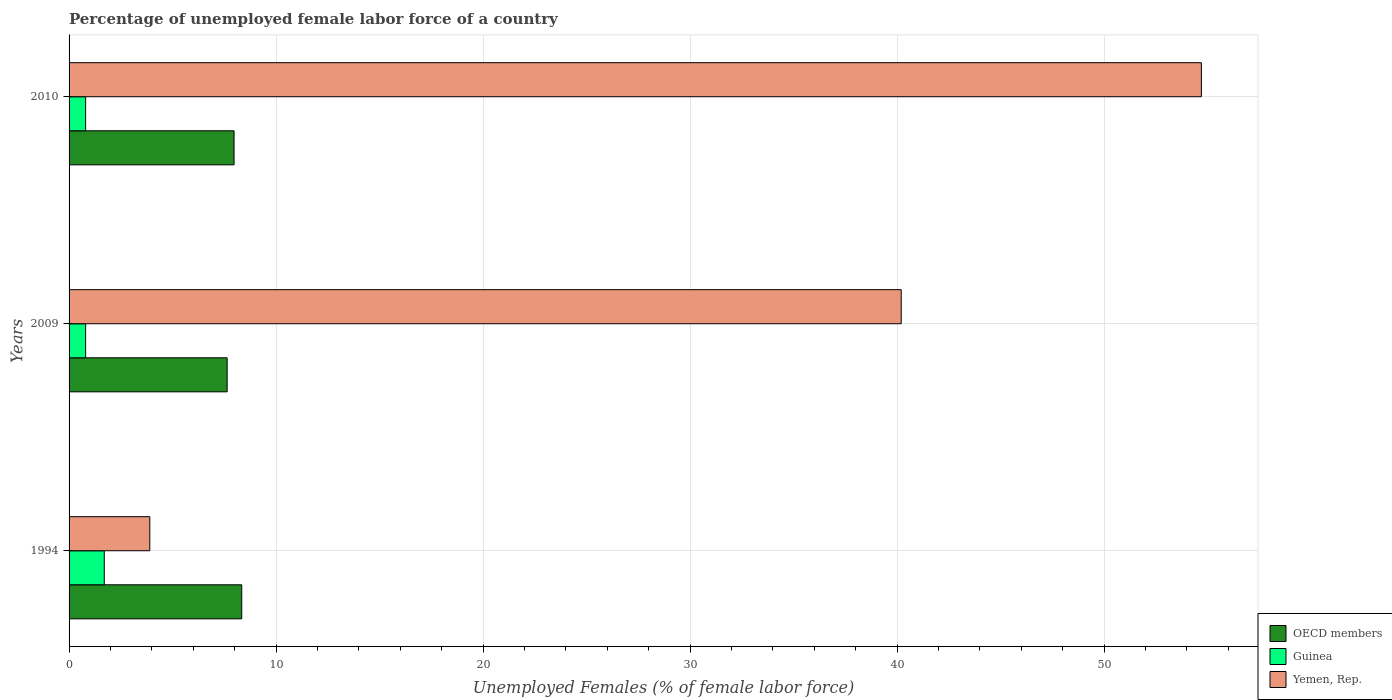How many different coloured bars are there?
Provide a short and direct response. 3. Are the number of bars on each tick of the Y-axis equal?
Your answer should be very brief. Yes. What is the percentage of unemployed female labor force in Guinea in 2009?
Your response must be concise. 0.8. Across all years, what is the maximum percentage of unemployed female labor force in OECD members?
Give a very brief answer. 8.34. Across all years, what is the minimum percentage of unemployed female labor force in Yemen, Rep.?
Keep it short and to the point. 3.9. In which year was the percentage of unemployed female labor force in OECD members maximum?
Provide a short and direct response. 1994. What is the total percentage of unemployed female labor force in Guinea in the graph?
Provide a short and direct response. 3.3. What is the difference between the percentage of unemployed female labor force in OECD members in 1994 and that in 2009?
Your answer should be very brief. 0.7. What is the difference between the percentage of unemployed female labor force in Guinea in 1994 and the percentage of unemployed female labor force in OECD members in 2009?
Offer a terse response. -5.94. What is the average percentage of unemployed female labor force in Guinea per year?
Give a very brief answer. 1.1. In the year 1994, what is the difference between the percentage of unemployed female labor force in Yemen, Rep. and percentage of unemployed female labor force in Guinea?
Your answer should be compact. 2.2. What is the ratio of the percentage of unemployed female labor force in OECD members in 2009 to that in 2010?
Offer a terse response. 0.96. What is the difference between the highest and the second highest percentage of unemployed female labor force in Guinea?
Provide a short and direct response. 0.9. What is the difference between the highest and the lowest percentage of unemployed female labor force in Guinea?
Ensure brevity in your answer.  0.9. Is the sum of the percentage of unemployed female labor force in Yemen, Rep. in 2009 and 2010 greater than the maximum percentage of unemployed female labor force in OECD members across all years?
Offer a very short reply. Yes. What does the 1st bar from the top in 1994 represents?
Give a very brief answer. Yemen, Rep. What does the 2nd bar from the bottom in 2010 represents?
Provide a succinct answer. Guinea. How many bars are there?
Offer a very short reply. 9. What is the difference between two consecutive major ticks on the X-axis?
Your response must be concise. 10. Are the values on the major ticks of X-axis written in scientific E-notation?
Give a very brief answer. No. Does the graph contain any zero values?
Offer a very short reply. No. Does the graph contain grids?
Make the answer very short. Yes. Where does the legend appear in the graph?
Your answer should be compact. Bottom right. How many legend labels are there?
Make the answer very short. 3. What is the title of the graph?
Your answer should be compact. Percentage of unemployed female labor force of a country. Does "Slovenia" appear as one of the legend labels in the graph?
Your answer should be very brief. No. What is the label or title of the X-axis?
Offer a terse response. Unemployed Females (% of female labor force). What is the label or title of the Y-axis?
Your response must be concise. Years. What is the Unemployed Females (% of female labor force) of OECD members in 1994?
Offer a terse response. 8.34. What is the Unemployed Females (% of female labor force) in Guinea in 1994?
Offer a very short reply. 1.7. What is the Unemployed Females (% of female labor force) in Yemen, Rep. in 1994?
Provide a succinct answer. 3.9. What is the Unemployed Females (% of female labor force) in OECD members in 2009?
Keep it short and to the point. 7.64. What is the Unemployed Females (% of female labor force) of Guinea in 2009?
Offer a very short reply. 0.8. What is the Unemployed Females (% of female labor force) in Yemen, Rep. in 2009?
Offer a very short reply. 40.2. What is the Unemployed Females (% of female labor force) in OECD members in 2010?
Make the answer very short. 7.97. What is the Unemployed Females (% of female labor force) in Guinea in 2010?
Offer a very short reply. 0.8. What is the Unemployed Females (% of female labor force) in Yemen, Rep. in 2010?
Offer a terse response. 54.7. Across all years, what is the maximum Unemployed Females (% of female labor force) of OECD members?
Provide a succinct answer. 8.34. Across all years, what is the maximum Unemployed Females (% of female labor force) in Guinea?
Your response must be concise. 1.7. Across all years, what is the maximum Unemployed Females (% of female labor force) in Yemen, Rep.?
Your answer should be compact. 54.7. Across all years, what is the minimum Unemployed Females (% of female labor force) in OECD members?
Offer a very short reply. 7.64. Across all years, what is the minimum Unemployed Females (% of female labor force) of Guinea?
Provide a short and direct response. 0.8. Across all years, what is the minimum Unemployed Females (% of female labor force) of Yemen, Rep.?
Give a very brief answer. 3.9. What is the total Unemployed Females (% of female labor force) of OECD members in the graph?
Your answer should be very brief. 23.95. What is the total Unemployed Females (% of female labor force) in Yemen, Rep. in the graph?
Keep it short and to the point. 98.8. What is the difference between the Unemployed Females (% of female labor force) in OECD members in 1994 and that in 2009?
Give a very brief answer. 0.7. What is the difference between the Unemployed Females (% of female labor force) in Guinea in 1994 and that in 2009?
Your answer should be compact. 0.9. What is the difference between the Unemployed Females (% of female labor force) of Yemen, Rep. in 1994 and that in 2009?
Make the answer very short. -36.3. What is the difference between the Unemployed Females (% of female labor force) in OECD members in 1994 and that in 2010?
Offer a terse response. 0.37. What is the difference between the Unemployed Females (% of female labor force) of Guinea in 1994 and that in 2010?
Your answer should be very brief. 0.9. What is the difference between the Unemployed Females (% of female labor force) in Yemen, Rep. in 1994 and that in 2010?
Provide a succinct answer. -50.8. What is the difference between the Unemployed Females (% of female labor force) in OECD members in 2009 and that in 2010?
Ensure brevity in your answer.  -0.33. What is the difference between the Unemployed Females (% of female labor force) in Yemen, Rep. in 2009 and that in 2010?
Your response must be concise. -14.5. What is the difference between the Unemployed Females (% of female labor force) of OECD members in 1994 and the Unemployed Females (% of female labor force) of Guinea in 2009?
Your answer should be compact. 7.54. What is the difference between the Unemployed Females (% of female labor force) of OECD members in 1994 and the Unemployed Females (% of female labor force) of Yemen, Rep. in 2009?
Keep it short and to the point. -31.86. What is the difference between the Unemployed Females (% of female labor force) in Guinea in 1994 and the Unemployed Females (% of female labor force) in Yemen, Rep. in 2009?
Ensure brevity in your answer.  -38.5. What is the difference between the Unemployed Females (% of female labor force) of OECD members in 1994 and the Unemployed Females (% of female labor force) of Guinea in 2010?
Make the answer very short. 7.54. What is the difference between the Unemployed Females (% of female labor force) in OECD members in 1994 and the Unemployed Females (% of female labor force) in Yemen, Rep. in 2010?
Make the answer very short. -46.36. What is the difference between the Unemployed Females (% of female labor force) in Guinea in 1994 and the Unemployed Females (% of female labor force) in Yemen, Rep. in 2010?
Give a very brief answer. -53. What is the difference between the Unemployed Females (% of female labor force) in OECD members in 2009 and the Unemployed Females (% of female labor force) in Guinea in 2010?
Provide a short and direct response. 6.84. What is the difference between the Unemployed Females (% of female labor force) in OECD members in 2009 and the Unemployed Females (% of female labor force) in Yemen, Rep. in 2010?
Your answer should be very brief. -47.06. What is the difference between the Unemployed Females (% of female labor force) in Guinea in 2009 and the Unemployed Females (% of female labor force) in Yemen, Rep. in 2010?
Keep it short and to the point. -53.9. What is the average Unemployed Females (% of female labor force) in OECD members per year?
Provide a short and direct response. 7.98. What is the average Unemployed Females (% of female labor force) in Guinea per year?
Provide a short and direct response. 1.1. What is the average Unemployed Females (% of female labor force) in Yemen, Rep. per year?
Make the answer very short. 32.93. In the year 1994, what is the difference between the Unemployed Females (% of female labor force) in OECD members and Unemployed Females (% of female labor force) in Guinea?
Offer a terse response. 6.64. In the year 1994, what is the difference between the Unemployed Females (% of female labor force) in OECD members and Unemployed Females (% of female labor force) in Yemen, Rep.?
Your response must be concise. 4.44. In the year 2009, what is the difference between the Unemployed Females (% of female labor force) of OECD members and Unemployed Females (% of female labor force) of Guinea?
Your answer should be very brief. 6.84. In the year 2009, what is the difference between the Unemployed Females (% of female labor force) of OECD members and Unemployed Females (% of female labor force) of Yemen, Rep.?
Offer a very short reply. -32.56. In the year 2009, what is the difference between the Unemployed Females (% of female labor force) in Guinea and Unemployed Females (% of female labor force) in Yemen, Rep.?
Provide a short and direct response. -39.4. In the year 2010, what is the difference between the Unemployed Females (% of female labor force) of OECD members and Unemployed Females (% of female labor force) of Guinea?
Make the answer very short. 7.17. In the year 2010, what is the difference between the Unemployed Females (% of female labor force) in OECD members and Unemployed Females (% of female labor force) in Yemen, Rep.?
Give a very brief answer. -46.73. In the year 2010, what is the difference between the Unemployed Females (% of female labor force) of Guinea and Unemployed Females (% of female labor force) of Yemen, Rep.?
Keep it short and to the point. -53.9. What is the ratio of the Unemployed Females (% of female labor force) of OECD members in 1994 to that in 2009?
Keep it short and to the point. 1.09. What is the ratio of the Unemployed Females (% of female labor force) in Guinea in 1994 to that in 2009?
Offer a terse response. 2.12. What is the ratio of the Unemployed Females (% of female labor force) of Yemen, Rep. in 1994 to that in 2009?
Make the answer very short. 0.1. What is the ratio of the Unemployed Females (% of female labor force) in OECD members in 1994 to that in 2010?
Offer a very short reply. 1.05. What is the ratio of the Unemployed Females (% of female labor force) of Guinea in 1994 to that in 2010?
Provide a short and direct response. 2.12. What is the ratio of the Unemployed Females (% of female labor force) of Yemen, Rep. in 1994 to that in 2010?
Keep it short and to the point. 0.07. What is the ratio of the Unemployed Females (% of female labor force) in OECD members in 2009 to that in 2010?
Offer a terse response. 0.96. What is the ratio of the Unemployed Females (% of female labor force) in Guinea in 2009 to that in 2010?
Make the answer very short. 1. What is the ratio of the Unemployed Females (% of female labor force) of Yemen, Rep. in 2009 to that in 2010?
Offer a very short reply. 0.73. What is the difference between the highest and the second highest Unemployed Females (% of female labor force) of OECD members?
Offer a terse response. 0.37. What is the difference between the highest and the second highest Unemployed Females (% of female labor force) of Guinea?
Make the answer very short. 0.9. What is the difference between the highest and the second highest Unemployed Females (% of female labor force) of Yemen, Rep.?
Your answer should be compact. 14.5. What is the difference between the highest and the lowest Unemployed Females (% of female labor force) of OECD members?
Your answer should be very brief. 0.7. What is the difference between the highest and the lowest Unemployed Females (% of female labor force) in Yemen, Rep.?
Provide a short and direct response. 50.8. 